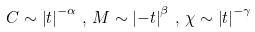Convert formula to latex. <formula><loc_0><loc_0><loc_500><loc_500>C \sim \left | t \right | ^ { - \alpha } \, , \, M \sim \left | - t \right | ^ { \beta } \, , \, \chi \sim \left | t \right | ^ { - \gamma }</formula> 